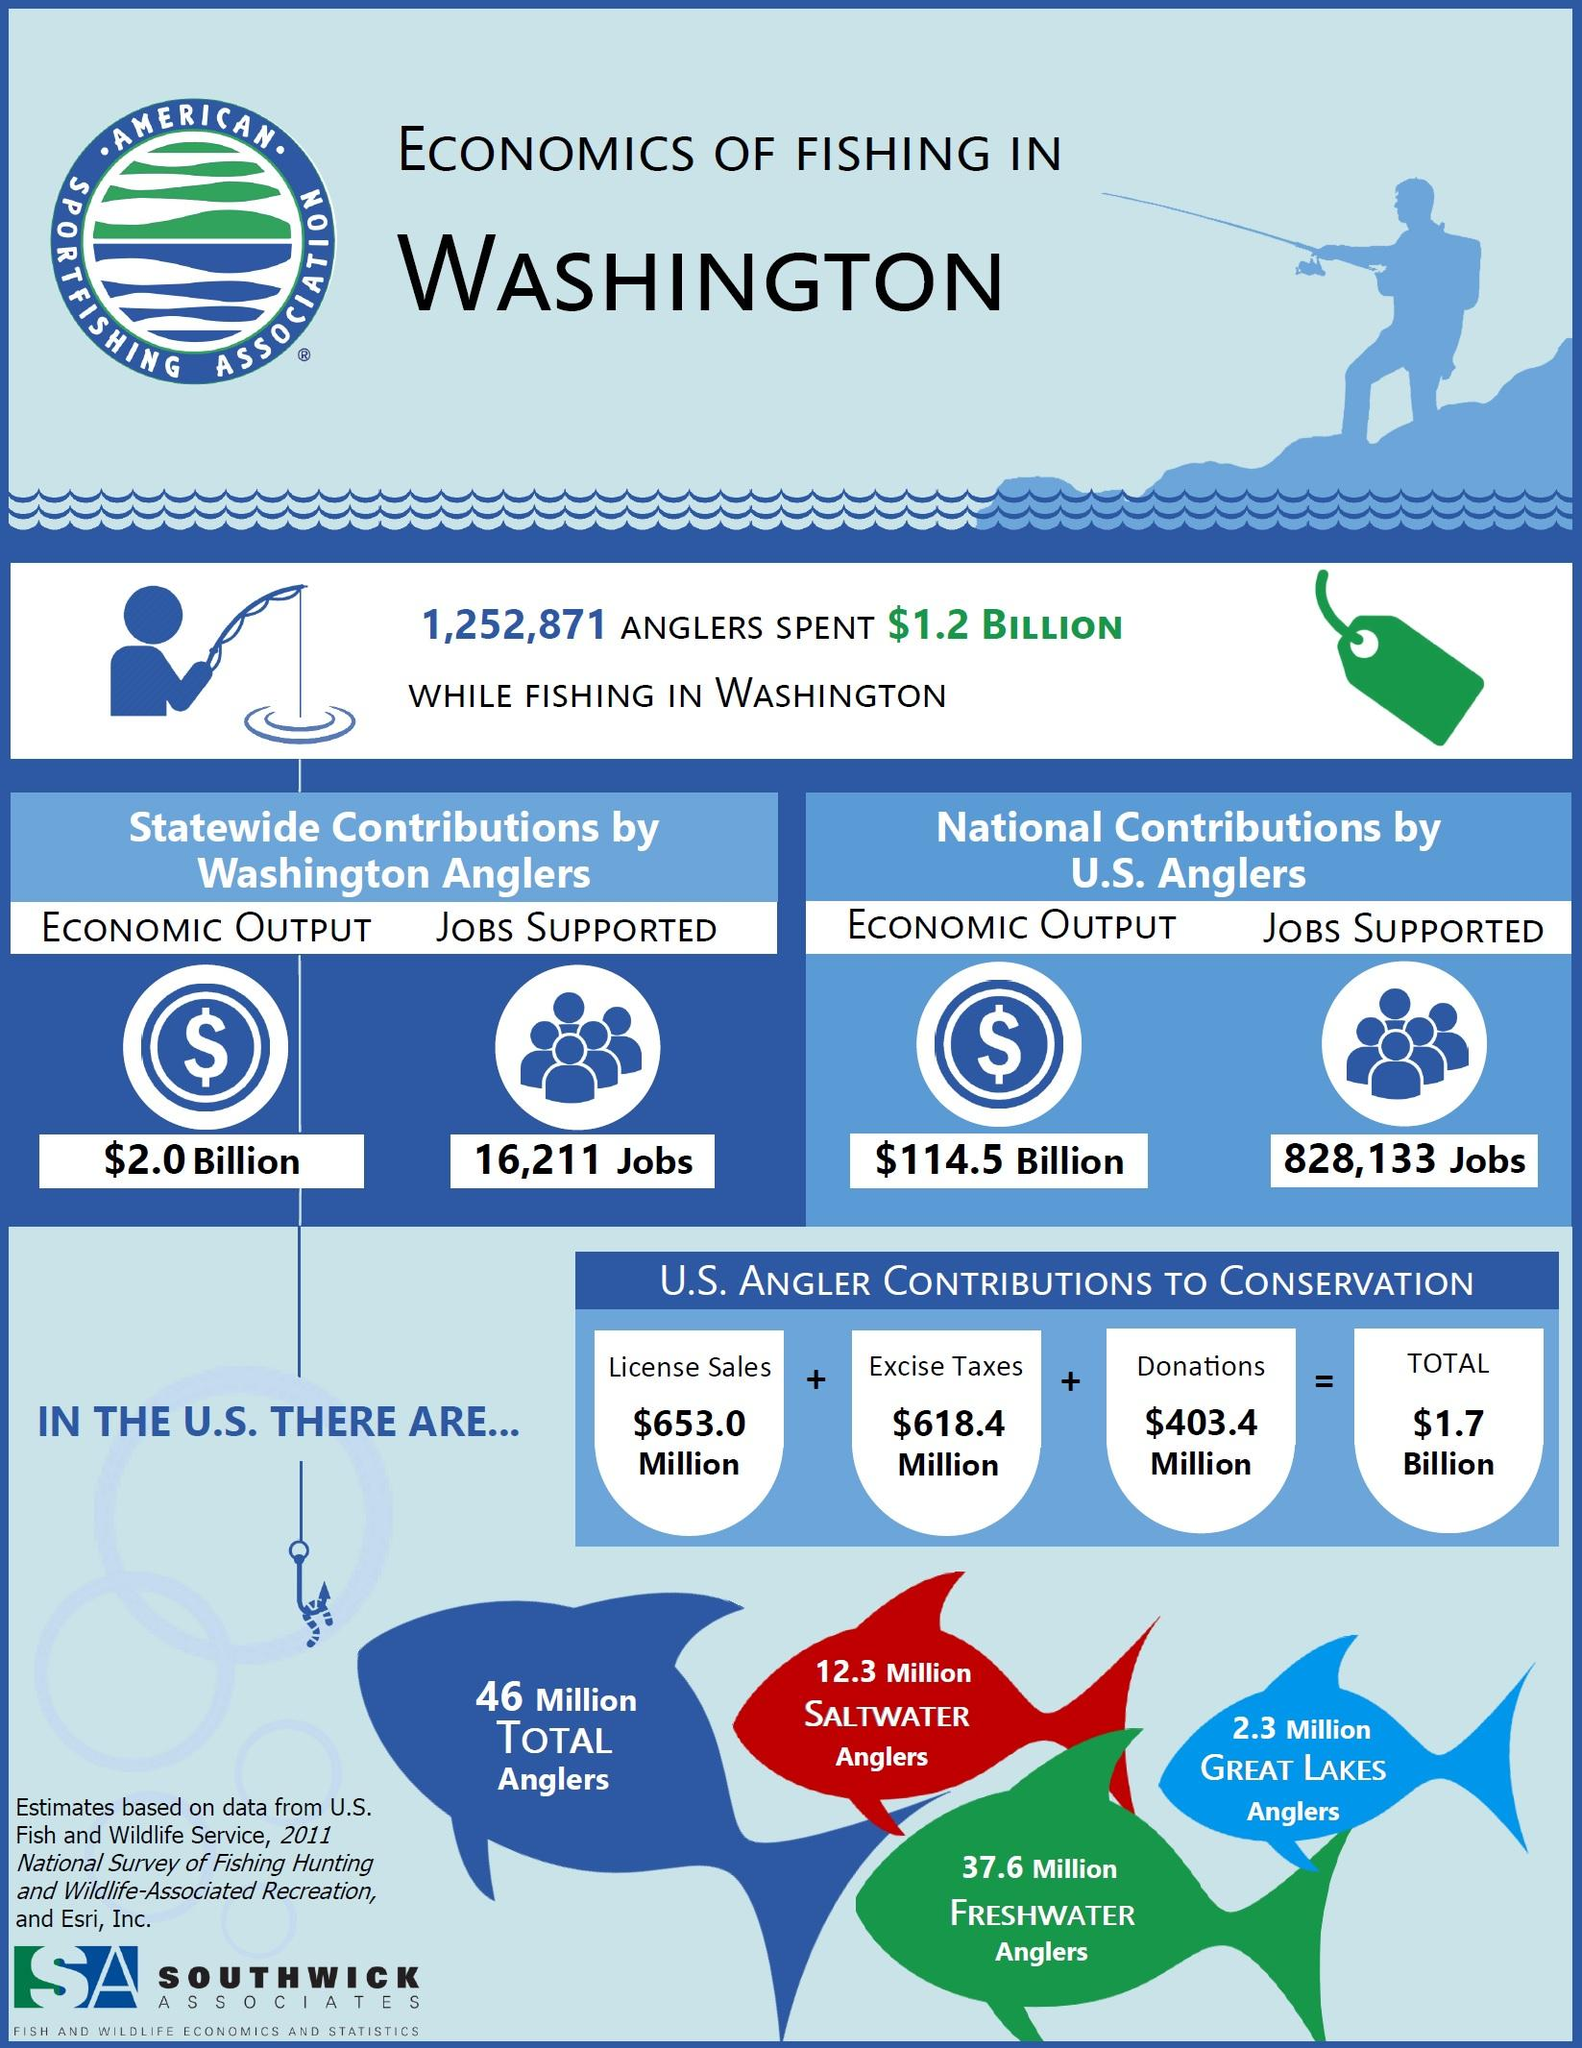Identify some key points in this picture. In the United States, anglers contributed a total of 1.2714 billion dollars in license sales and excise taxes. The economic output generated by the statewide contributions of Washington anglers is significantly different from the national contributions by U.S. anglers, resulting in a difference of $112.5 billion. There are approximately 49.9 million saltwater and freshwater anglers in the United States. The economic output generated by Washington anglers statewide is estimated to be $2.0 billion. 